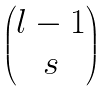Convert formula to latex. <formula><loc_0><loc_0><loc_500><loc_500>\begin{pmatrix} l - 1 \\ s \end{pmatrix}</formula> 